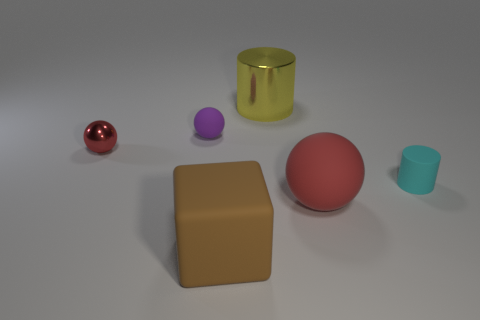Are there any big blocks made of the same material as the purple object?
Ensure brevity in your answer.  Yes. There is a matte ball that is the same color as the tiny metal thing; what is its size?
Ensure brevity in your answer.  Large. Is the number of small rubber cylinders less than the number of large green matte balls?
Keep it short and to the point. No. Do the matte sphere in front of the rubber cylinder and the metallic ball have the same color?
Your answer should be compact. Yes. The red object that is in front of the thing to the right of the rubber ball that is in front of the small purple rubber object is made of what material?
Offer a very short reply. Rubber. Are there any large rubber spheres of the same color as the small metal ball?
Your answer should be compact. Yes. Are there fewer small spheres in front of the purple matte sphere than red balls?
Offer a terse response. Yes. Do the thing that is on the left side of the purple object and the tiny cyan rubber cylinder have the same size?
Give a very brief answer. Yes. How many things are in front of the big metal object and on the right side of the brown cube?
Ensure brevity in your answer.  2. How big is the red sphere to the right of the big thing that is behind the rubber cylinder?
Your response must be concise. Large. 